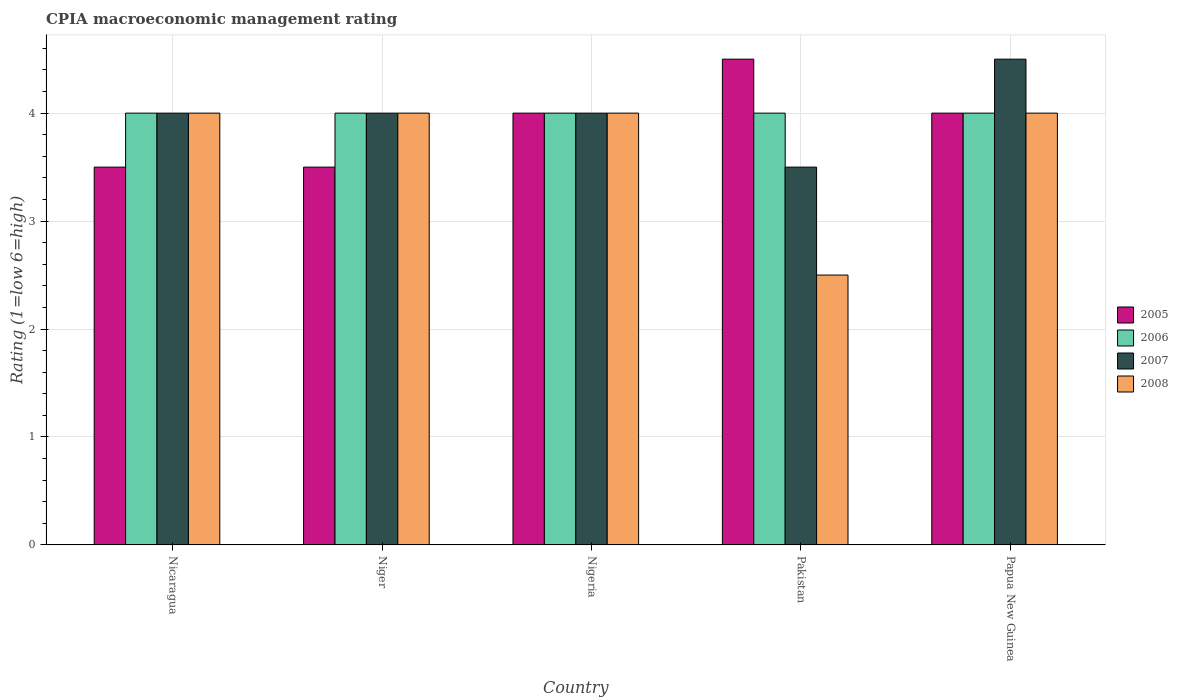How many different coloured bars are there?
Provide a short and direct response. 4. How many groups of bars are there?
Your response must be concise. 5. How many bars are there on the 4th tick from the right?
Your answer should be compact. 4. What is the label of the 1st group of bars from the left?
Your answer should be compact. Nicaragua. What is the CPIA rating in 2007 in Nigeria?
Your answer should be compact. 4. In which country was the CPIA rating in 2007 maximum?
Offer a very short reply. Papua New Guinea. What is the total CPIA rating in 2008 in the graph?
Your answer should be compact. 18.5. What is the difference between the CPIA rating in 2005 in Nicaragua and that in Pakistan?
Offer a terse response. -1. What is the difference between the CPIA rating in 2006 in Pakistan and the CPIA rating in 2007 in Niger?
Offer a terse response. 0. What is the difference between the CPIA rating of/in 2008 and CPIA rating of/in 2007 in Nigeria?
Offer a terse response. 0. Is the CPIA rating in 2005 in Nicaragua less than that in Papua New Guinea?
Provide a short and direct response. Yes. What is the difference between the highest and the second highest CPIA rating in 2007?
Keep it short and to the point. 0.5. In how many countries, is the CPIA rating in 2006 greater than the average CPIA rating in 2006 taken over all countries?
Give a very brief answer. 0. Is the sum of the CPIA rating in 2008 in Nicaragua and Pakistan greater than the maximum CPIA rating in 2007 across all countries?
Provide a short and direct response. Yes. Is it the case that in every country, the sum of the CPIA rating in 2006 and CPIA rating in 2005 is greater than the sum of CPIA rating in 2007 and CPIA rating in 2008?
Offer a very short reply. No. What does the 4th bar from the left in Nicaragua represents?
Ensure brevity in your answer.  2008. What does the 1st bar from the right in Papua New Guinea represents?
Ensure brevity in your answer.  2008. What is the difference between two consecutive major ticks on the Y-axis?
Provide a succinct answer. 1. Are the values on the major ticks of Y-axis written in scientific E-notation?
Keep it short and to the point. No. Does the graph contain any zero values?
Keep it short and to the point. No. How many legend labels are there?
Make the answer very short. 4. How are the legend labels stacked?
Your answer should be very brief. Vertical. What is the title of the graph?
Your answer should be compact. CPIA macroeconomic management rating. What is the label or title of the X-axis?
Keep it short and to the point. Country. What is the label or title of the Y-axis?
Your answer should be very brief. Rating (1=low 6=high). What is the Rating (1=low 6=high) in 2005 in Nicaragua?
Your response must be concise. 3.5. What is the Rating (1=low 6=high) in 2006 in Nicaragua?
Your answer should be very brief. 4. What is the Rating (1=low 6=high) in 2007 in Nicaragua?
Your response must be concise. 4. What is the Rating (1=low 6=high) of 2006 in Niger?
Your answer should be compact. 4. What is the Rating (1=low 6=high) of 2006 in Nigeria?
Provide a succinct answer. 4. What is the Rating (1=low 6=high) in 2007 in Nigeria?
Provide a succinct answer. 4. What is the Rating (1=low 6=high) in 2005 in Papua New Guinea?
Give a very brief answer. 4. What is the Rating (1=low 6=high) in 2008 in Papua New Guinea?
Make the answer very short. 4. Across all countries, what is the maximum Rating (1=low 6=high) in 2005?
Offer a terse response. 4.5. Across all countries, what is the minimum Rating (1=low 6=high) of 2005?
Make the answer very short. 3.5. Across all countries, what is the minimum Rating (1=low 6=high) in 2006?
Ensure brevity in your answer.  4. Across all countries, what is the minimum Rating (1=low 6=high) of 2007?
Ensure brevity in your answer.  3.5. What is the total Rating (1=low 6=high) of 2005 in the graph?
Offer a very short reply. 19.5. What is the total Rating (1=low 6=high) of 2006 in the graph?
Make the answer very short. 20. What is the difference between the Rating (1=low 6=high) in 2005 in Nicaragua and that in Niger?
Offer a terse response. 0. What is the difference between the Rating (1=low 6=high) of 2005 in Nicaragua and that in Nigeria?
Your answer should be very brief. -0.5. What is the difference between the Rating (1=low 6=high) in 2008 in Nicaragua and that in Nigeria?
Provide a short and direct response. 0. What is the difference between the Rating (1=low 6=high) in 2006 in Nicaragua and that in Pakistan?
Provide a short and direct response. 0. What is the difference between the Rating (1=low 6=high) in 2007 in Nicaragua and that in Pakistan?
Your answer should be compact. 0.5. What is the difference between the Rating (1=low 6=high) in 2006 in Nicaragua and that in Papua New Guinea?
Keep it short and to the point. 0. What is the difference between the Rating (1=low 6=high) in 2007 in Nicaragua and that in Papua New Guinea?
Your answer should be compact. -0.5. What is the difference between the Rating (1=low 6=high) in 2008 in Nicaragua and that in Papua New Guinea?
Your answer should be very brief. 0. What is the difference between the Rating (1=low 6=high) of 2005 in Niger and that in Nigeria?
Make the answer very short. -0.5. What is the difference between the Rating (1=low 6=high) in 2007 in Niger and that in Nigeria?
Provide a short and direct response. 0. What is the difference between the Rating (1=low 6=high) in 2006 in Niger and that in Pakistan?
Keep it short and to the point. 0. What is the difference between the Rating (1=low 6=high) in 2007 in Niger and that in Pakistan?
Keep it short and to the point. 0.5. What is the difference between the Rating (1=low 6=high) of 2008 in Niger and that in Pakistan?
Your answer should be compact. 1.5. What is the difference between the Rating (1=low 6=high) in 2006 in Niger and that in Papua New Guinea?
Your answer should be very brief. 0. What is the difference between the Rating (1=low 6=high) in 2007 in Nigeria and that in Pakistan?
Offer a terse response. 0.5. What is the difference between the Rating (1=low 6=high) of 2005 in Nigeria and that in Papua New Guinea?
Your answer should be very brief. 0. What is the difference between the Rating (1=low 6=high) in 2006 in Nigeria and that in Papua New Guinea?
Offer a very short reply. 0. What is the difference between the Rating (1=low 6=high) in 2008 in Nigeria and that in Papua New Guinea?
Give a very brief answer. 0. What is the difference between the Rating (1=low 6=high) in 2005 in Nicaragua and the Rating (1=low 6=high) in 2006 in Niger?
Your answer should be very brief. -0.5. What is the difference between the Rating (1=low 6=high) of 2005 in Nicaragua and the Rating (1=low 6=high) of 2007 in Niger?
Ensure brevity in your answer.  -0.5. What is the difference between the Rating (1=low 6=high) of 2005 in Nicaragua and the Rating (1=low 6=high) of 2006 in Nigeria?
Your answer should be very brief. -0.5. What is the difference between the Rating (1=low 6=high) of 2005 in Nicaragua and the Rating (1=low 6=high) of 2008 in Nigeria?
Provide a succinct answer. -0.5. What is the difference between the Rating (1=low 6=high) in 2006 in Nicaragua and the Rating (1=low 6=high) in 2007 in Nigeria?
Your answer should be compact. 0. What is the difference between the Rating (1=low 6=high) in 2007 in Nicaragua and the Rating (1=low 6=high) in 2008 in Nigeria?
Give a very brief answer. 0. What is the difference between the Rating (1=low 6=high) of 2005 in Nicaragua and the Rating (1=low 6=high) of 2007 in Pakistan?
Give a very brief answer. 0. What is the difference between the Rating (1=low 6=high) of 2005 in Nicaragua and the Rating (1=low 6=high) of 2008 in Pakistan?
Your response must be concise. 1. What is the difference between the Rating (1=low 6=high) in 2005 in Nicaragua and the Rating (1=low 6=high) in 2008 in Papua New Guinea?
Your answer should be very brief. -0.5. What is the difference between the Rating (1=low 6=high) in 2006 in Nicaragua and the Rating (1=low 6=high) in 2007 in Papua New Guinea?
Make the answer very short. -0.5. What is the difference between the Rating (1=low 6=high) in 2006 in Nicaragua and the Rating (1=low 6=high) in 2008 in Papua New Guinea?
Your response must be concise. 0. What is the difference between the Rating (1=low 6=high) in 2007 in Nicaragua and the Rating (1=low 6=high) in 2008 in Papua New Guinea?
Offer a very short reply. 0. What is the difference between the Rating (1=low 6=high) in 2005 in Niger and the Rating (1=low 6=high) in 2008 in Nigeria?
Offer a terse response. -0.5. What is the difference between the Rating (1=low 6=high) of 2006 in Niger and the Rating (1=low 6=high) of 2008 in Nigeria?
Provide a succinct answer. 0. What is the difference between the Rating (1=low 6=high) of 2007 in Niger and the Rating (1=low 6=high) of 2008 in Nigeria?
Give a very brief answer. 0. What is the difference between the Rating (1=low 6=high) of 2005 in Niger and the Rating (1=low 6=high) of 2006 in Pakistan?
Your answer should be very brief. -0.5. What is the difference between the Rating (1=low 6=high) in 2005 in Niger and the Rating (1=low 6=high) in 2007 in Pakistan?
Provide a succinct answer. 0. What is the difference between the Rating (1=low 6=high) in 2005 in Niger and the Rating (1=low 6=high) in 2008 in Pakistan?
Ensure brevity in your answer.  1. What is the difference between the Rating (1=low 6=high) of 2006 in Niger and the Rating (1=low 6=high) of 2008 in Pakistan?
Give a very brief answer. 1.5. What is the difference between the Rating (1=low 6=high) of 2005 in Niger and the Rating (1=low 6=high) of 2006 in Papua New Guinea?
Your answer should be compact. -0.5. What is the difference between the Rating (1=low 6=high) of 2006 in Niger and the Rating (1=low 6=high) of 2007 in Papua New Guinea?
Ensure brevity in your answer.  -0.5. What is the difference between the Rating (1=low 6=high) in 2005 in Nigeria and the Rating (1=low 6=high) in 2006 in Pakistan?
Provide a short and direct response. 0. What is the difference between the Rating (1=low 6=high) in 2005 in Nigeria and the Rating (1=low 6=high) in 2007 in Pakistan?
Offer a terse response. 0.5. What is the difference between the Rating (1=low 6=high) in 2006 in Nigeria and the Rating (1=low 6=high) in 2007 in Pakistan?
Offer a terse response. 0.5. What is the difference between the Rating (1=low 6=high) in 2006 in Nigeria and the Rating (1=low 6=high) in 2008 in Pakistan?
Your response must be concise. 1.5. What is the difference between the Rating (1=low 6=high) in 2007 in Nigeria and the Rating (1=low 6=high) in 2008 in Pakistan?
Offer a very short reply. 1.5. What is the difference between the Rating (1=low 6=high) of 2005 in Nigeria and the Rating (1=low 6=high) of 2006 in Papua New Guinea?
Provide a succinct answer. 0. What is the difference between the Rating (1=low 6=high) in 2005 in Nigeria and the Rating (1=low 6=high) in 2007 in Papua New Guinea?
Your answer should be compact. -0.5. What is the difference between the Rating (1=low 6=high) of 2006 in Nigeria and the Rating (1=low 6=high) of 2007 in Papua New Guinea?
Your response must be concise. -0.5. What is the difference between the Rating (1=low 6=high) in 2007 in Nigeria and the Rating (1=low 6=high) in 2008 in Papua New Guinea?
Your response must be concise. 0. What is the difference between the Rating (1=low 6=high) of 2005 in Pakistan and the Rating (1=low 6=high) of 2006 in Papua New Guinea?
Ensure brevity in your answer.  0.5. What is the difference between the Rating (1=low 6=high) of 2005 in Pakistan and the Rating (1=low 6=high) of 2007 in Papua New Guinea?
Ensure brevity in your answer.  0. What is the difference between the Rating (1=low 6=high) in 2006 in Pakistan and the Rating (1=low 6=high) in 2007 in Papua New Guinea?
Offer a terse response. -0.5. What is the average Rating (1=low 6=high) in 2005 per country?
Your response must be concise. 3.9. What is the average Rating (1=low 6=high) in 2006 per country?
Provide a short and direct response. 4. What is the average Rating (1=low 6=high) in 2008 per country?
Your answer should be compact. 3.7. What is the difference between the Rating (1=low 6=high) of 2005 and Rating (1=low 6=high) of 2006 in Nicaragua?
Your response must be concise. -0.5. What is the difference between the Rating (1=low 6=high) of 2005 and Rating (1=low 6=high) of 2007 in Nicaragua?
Provide a succinct answer. -0.5. What is the difference between the Rating (1=low 6=high) of 2006 and Rating (1=low 6=high) of 2007 in Nicaragua?
Provide a succinct answer. 0. What is the difference between the Rating (1=low 6=high) in 2006 and Rating (1=low 6=high) in 2008 in Nicaragua?
Your answer should be compact. 0. What is the difference between the Rating (1=low 6=high) of 2007 and Rating (1=low 6=high) of 2008 in Nicaragua?
Your answer should be compact. 0. What is the difference between the Rating (1=low 6=high) in 2006 and Rating (1=low 6=high) in 2007 in Niger?
Provide a short and direct response. 0. What is the difference between the Rating (1=low 6=high) of 2006 and Rating (1=low 6=high) of 2008 in Niger?
Offer a terse response. 0. What is the difference between the Rating (1=low 6=high) of 2007 and Rating (1=low 6=high) of 2008 in Niger?
Provide a succinct answer. 0. What is the difference between the Rating (1=low 6=high) in 2005 and Rating (1=low 6=high) in 2007 in Nigeria?
Provide a succinct answer. 0. What is the difference between the Rating (1=low 6=high) of 2005 and Rating (1=low 6=high) of 2008 in Nigeria?
Your answer should be very brief. 0. What is the difference between the Rating (1=low 6=high) of 2006 and Rating (1=low 6=high) of 2007 in Nigeria?
Give a very brief answer. 0. What is the difference between the Rating (1=low 6=high) of 2006 and Rating (1=low 6=high) of 2008 in Nigeria?
Your answer should be compact. 0. What is the difference between the Rating (1=low 6=high) in 2007 and Rating (1=low 6=high) in 2008 in Nigeria?
Keep it short and to the point. 0. What is the difference between the Rating (1=low 6=high) in 2005 and Rating (1=low 6=high) in 2008 in Pakistan?
Provide a succinct answer. 2. What is the difference between the Rating (1=low 6=high) in 2005 and Rating (1=low 6=high) in 2006 in Papua New Guinea?
Give a very brief answer. 0. What is the difference between the Rating (1=low 6=high) of 2005 and Rating (1=low 6=high) of 2008 in Papua New Guinea?
Make the answer very short. 0. What is the difference between the Rating (1=low 6=high) in 2006 and Rating (1=low 6=high) in 2007 in Papua New Guinea?
Provide a succinct answer. -0.5. What is the difference between the Rating (1=low 6=high) of 2006 and Rating (1=low 6=high) of 2008 in Papua New Guinea?
Provide a short and direct response. 0. What is the ratio of the Rating (1=low 6=high) of 2007 in Nicaragua to that in Niger?
Ensure brevity in your answer.  1. What is the ratio of the Rating (1=low 6=high) in 2008 in Nicaragua to that in Niger?
Your response must be concise. 1. What is the ratio of the Rating (1=low 6=high) of 2006 in Nicaragua to that in Pakistan?
Make the answer very short. 1. What is the ratio of the Rating (1=low 6=high) of 2007 in Nicaragua to that in Pakistan?
Provide a succinct answer. 1.14. What is the ratio of the Rating (1=low 6=high) of 2008 in Nicaragua to that in Papua New Guinea?
Provide a short and direct response. 1. What is the ratio of the Rating (1=low 6=high) of 2005 in Niger to that in Nigeria?
Offer a terse response. 0.88. What is the ratio of the Rating (1=low 6=high) in 2006 in Niger to that in Nigeria?
Keep it short and to the point. 1. What is the ratio of the Rating (1=low 6=high) of 2005 in Niger to that in Pakistan?
Keep it short and to the point. 0.78. What is the ratio of the Rating (1=low 6=high) in 2005 in Niger to that in Papua New Guinea?
Your response must be concise. 0.88. What is the ratio of the Rating (1=low 6=high) in 2008 in Niger to that in Papua New Guinea?
Keep it short and to the point. 1. What is the ratio of the Rating (1=low 6=high) of 2005 in Nigeria to that in Pakistan?
Make the answer very short. 0.89. What is the ratio of the Rating (1=low 6=high) in 2006 in Nigeria to that in Pakistan?
Provide a succinct answer. 1. What is the ratio of the Rating (1=low 6=high) in 2008 in Nigeria to that in Pakistan?
Ensure brevity in your answer.  1.6. What is the ratio of the Rating (1=low 6=high) in 2006 in Nigeria to that in Papua New Guinea?
Your answer should be compact. 1. What is the ratio of the Rating (1=low 6=high) in 2008 in Nigeria to that in Papua New Guinea?
Provide a succinct answer. 1. What is the ratio of the Rating (1=low 6=high) in 2005 in Pakistan to that in Papua New Guinea?
Provide a succinct answer. 1.12. What is the ratio of the Rating (1=low 6=high) in 2006 in Pakistan to that in Papua New Guinea?
Offer a very short reply. 1. What is the ratio of the Rating (1=low 6=high) in 2007 in Pakistan to that in Papua New Guinea?
Offer a very short reply. 0.78. What is the ratio of the Rating (1=low 6=high) in 2008 in Pakistan to that in Papua New Guinea?
Provide a succinct answer. 0.62. What is the difference between the highest and the second highest Rating (1=low 6=high) of 2005?
Offer a terse response. 0.5. What is the difference between the highest and the second highest Rating (1=low 6=high) of 2006?
Ensure brevity in your answer.  0. What is the difference between the highest and the second highest Rating (1=low 6=high) in 2007?
Provide a succinct answer. 0.5. What is the difference between the highest and the second highest Rating (1=low 6=high) in 2008?
Your response must be concise. 0. 